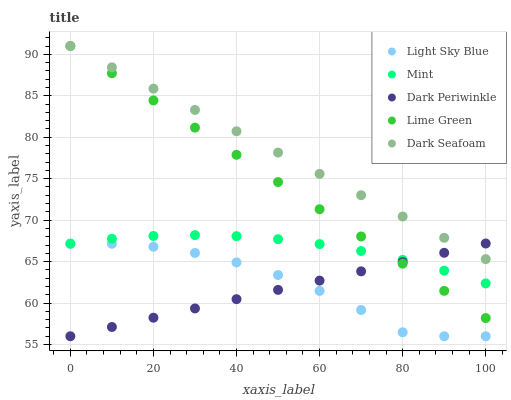Does Dark Periwinkle have the minimum area under the curve?
Answer yes or no. Yes. Does Dark Seafoam have the maximum area under the curve?
Answer yes or no. Yes. Does Light Sky Blue have the minimum area under the curve?
Answer yes or no. No. Does Light Sky Blue have the maximum area under the curve?
Answer yes or no. No. Is Dark Periwinkle the smoothest?
Answer yes or no. Yes. Is Light Sky Blue the roughest?
Answer yes or no. Yes. Is Dark Seafoam the smoothest?
Answer yes or no. No. Is Dark Seafoam the roughest?
Answer yes or no. No. Does Light Sky Blue have the lowest value?
Answer yes or no. Yes. Does Dark Seafoam have the lowest value?
Answer yes or no. No. Does Dark Seafoam have the highest value?
Answer yes or no. Yes. Does Light Sky Blue have the highest value?
Answer yes or no. No. Is Light Sky Blue less than Mint?
Answer yes or no. Yes. Is Mint greater than Light Sky Blue?
Answer yes or no. Yes. Does Lime Green intersect Mint?
Answer yes or no. Yes. Is Lime Green less than Mint?
Answer yes or no. No. Is Lime Green greater than Mint?
Answer yes or no. No. Does Light Sky Blue intersect Mint?
Answer yes or no. No. 